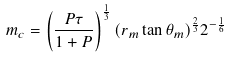Convert formula to latex. <formula><loc_0><loc_0><loc_500><loc_500>m _ { c } = \left ( \frac { P \tau } { 1 + P } \right ) ^ { \frac { 1 } { 3 } } ( r _ { m } \tan \theta _ { m } ) ^ { \frac { 2 } { 3 } } 2 ^ { - \frac { 1 } { 6 } }</formula> 